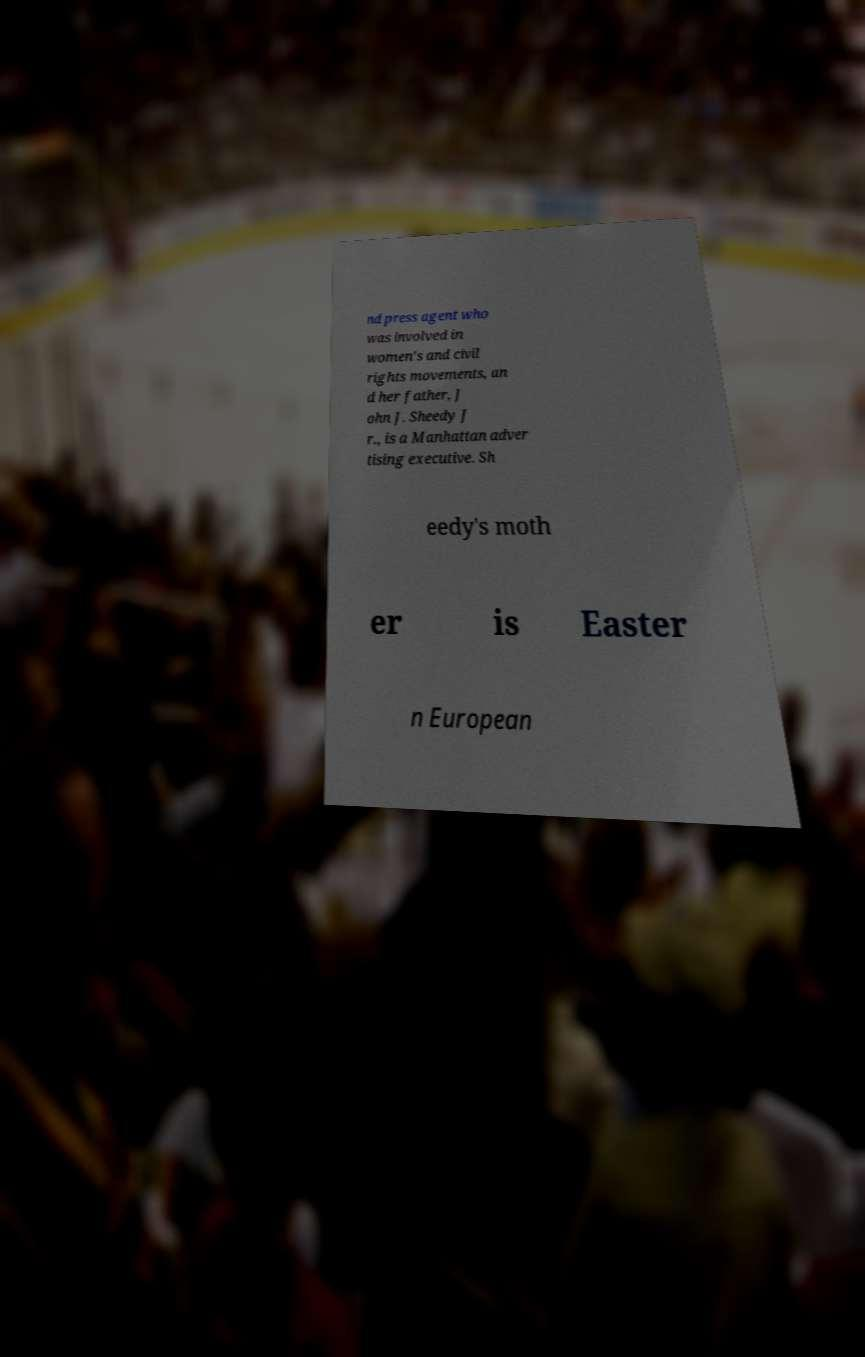There's text embedded in this image that I need extracted. Can you transcribe it verbatim? nd press agent who was involved in women's and civil rights movements, an d her father, J ohn J. Sheedy J r., is a Manhattan adver tising executive. Sh eedy's moth er is Easter n European 